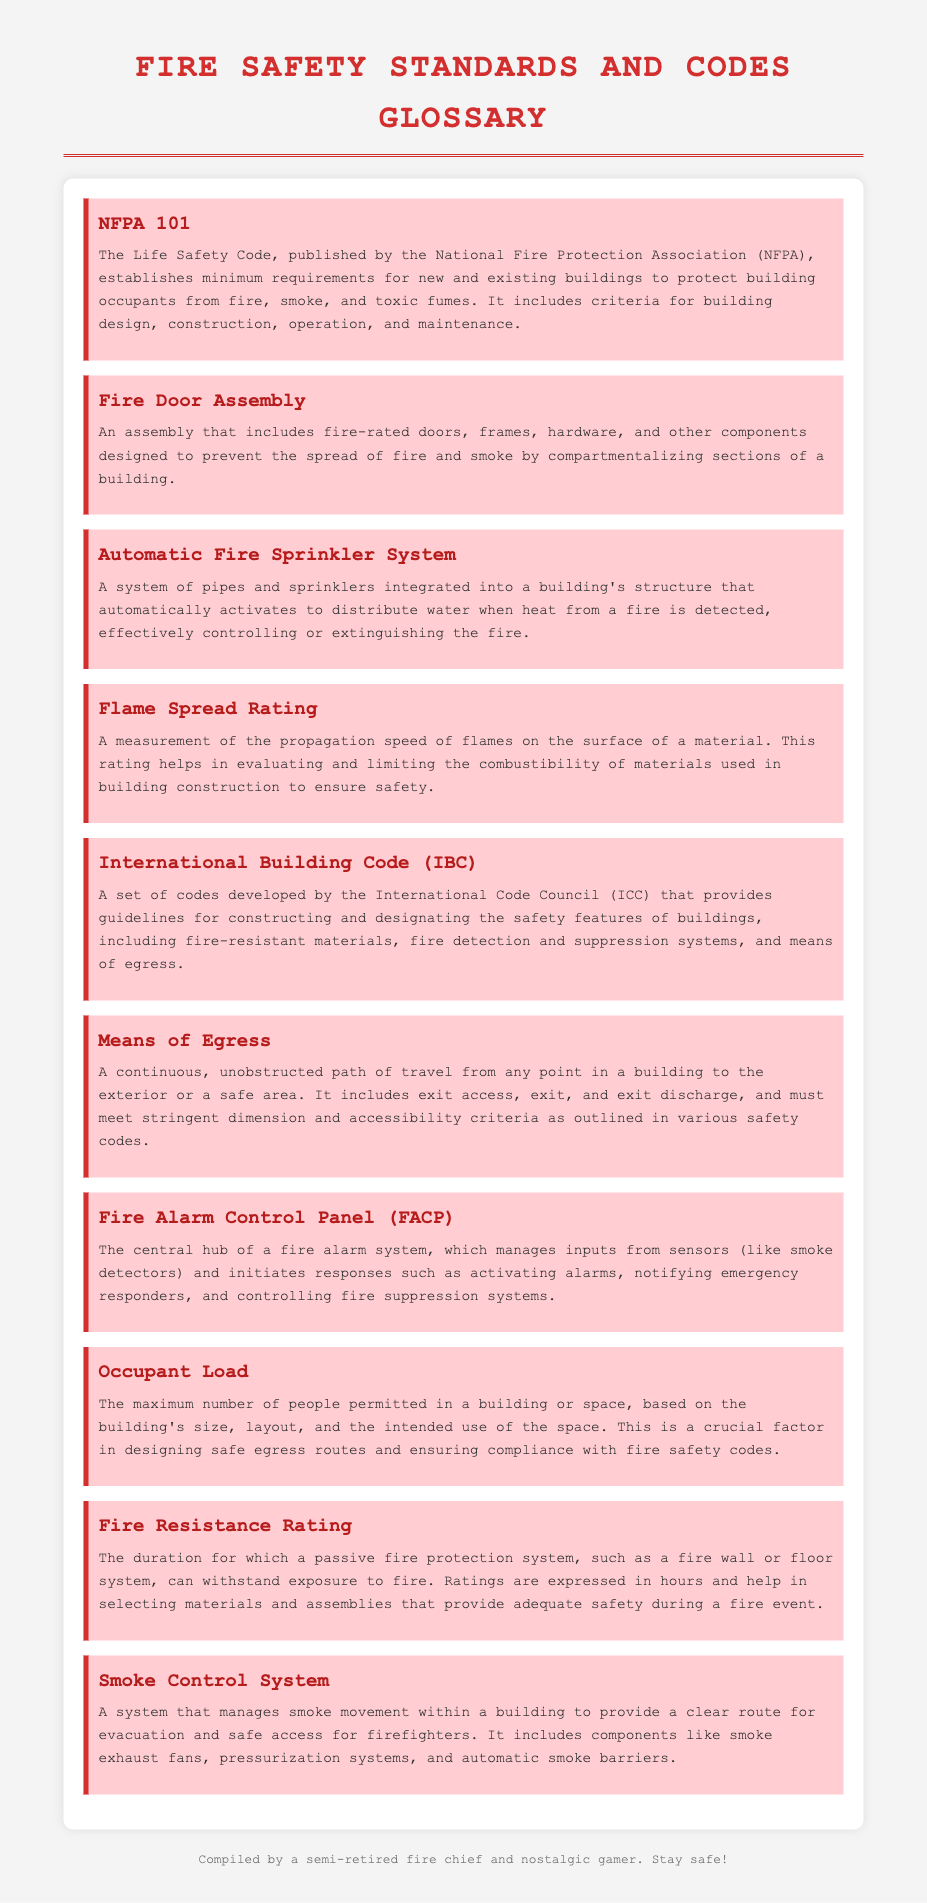What does NFPA 101 stand for? NFPA 101 is defined in the document as the Life Safety Code published by the National Fire Protection Association.
Answer: Life Safety Code What is included in a Fire Door Assembly? The definition states that a Fire Door Assembly includes fire-rated doors, frames, hardware, and other components.
Answer: Fire-rated doors, frames, hardware, and other components What is the purpose of an Automatic Fire Sprinkler System? The definition mentions that it automatically activates to distribute water when heat from a fire is detected.
Answer: Distribute water What does Means of Egress refer to? The document defines Means of Egress as a continuous, unobstructed path of travel from any point in a building to the exterior.
Answer: Continuous, unobstructed path What would be typically included in the International Building Code? The definition states that it provides guidelines for constructing and designating the safety features of buildings.
Answer: Guidelines for constructing and safety features How does the Flame Spread Rating contribute to fire safety? The definition indicates that it evaluates and limits the combustibility of materials used in building construction.
Answer: Evaluates and limits combustibility What is the role of the Fire Alarm Control Panel (FACP)? The document explains that it manages inputs from sensors and initiates responses such as activating alarms.
Answer: Manages inputs and initiates responses What is the Fire Resistance Rating expressed in? The document states that it is expressed in hours, indicating the duration for which a system can withstand fire.
Answer: Hours What is the function of a Smoke Control System? The definition describes it as managing smoke movement within a building to provide a clear route for evacuation.
Answer: Managing smoke movement How is the Occupant Load determined? The document indicates that it is based on the building's size, layout, and intended use of the space.
Answer: Building's size, layout, and intended use 